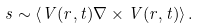<formula> <loc_0><loc_0><loc_500><loc_500>s \sim \left \langle { V } ( { r } , t ) \nabla \times { V } ( { r } , t ) \right \rangle .</formula> 